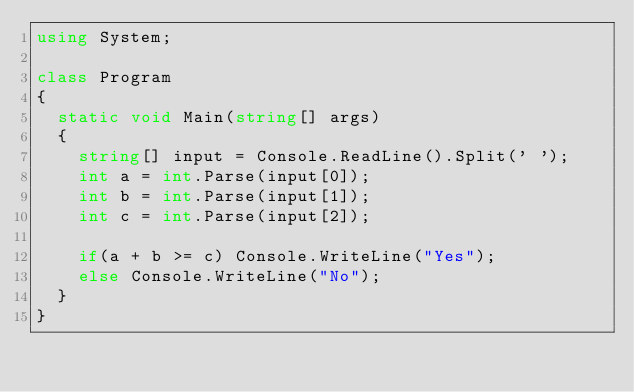Convert code to text. <code><loc_0><loc_0><loc_500><loc_500><_C#_>using System;

class Program
{
  static void Main(string[] args)
  {
    string[] input = Console.ReadLine().Split(' ');
    int a = int.Parse(input[0]);
    int b = int.Parse(input[1]);
    int c = int.Parse(input[2]);
    
    if(a + b >= c) Console.WriteLine("Yes");
    else Console.WriteLine("No");
  }
}</code> 